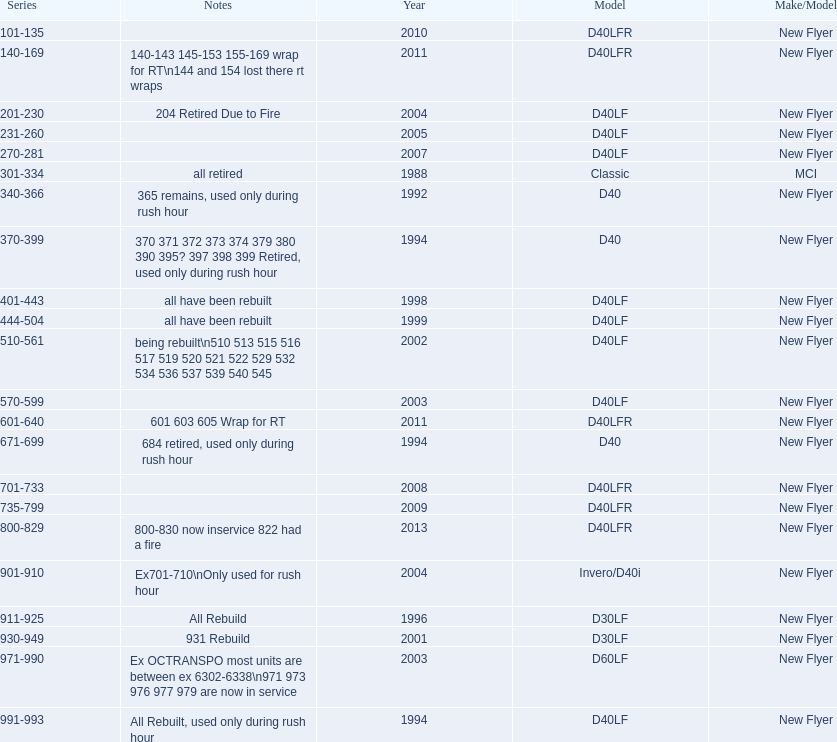What are all the series of buses? 101-135, 140-169, 201-230, 231-260, 270-281, 301-334, 340-366, 370-399, 401-443, 444-504, 510-561, 570-599, 601-640, 671-699, 701-733, 735-799, 800-829, 901-910, 911-925, 930-949, 971-990, 991-993. Which are the newest? 800-829. 